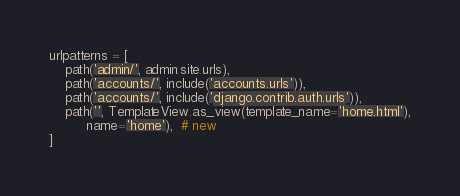Convert code to text. <code><loc_0><loc_0><loc_500><loc_500><_Python_>
urlpatterns = [
    path('admin/', admin.site.urls),
    path('accounts/', include('accounts.urls')),
    path('accounts/', include('django.contrib.auth.urls')),
    path('', TemplateView.as_view(template_name='home.html'),
         name='home'),  # new
]
</code> 